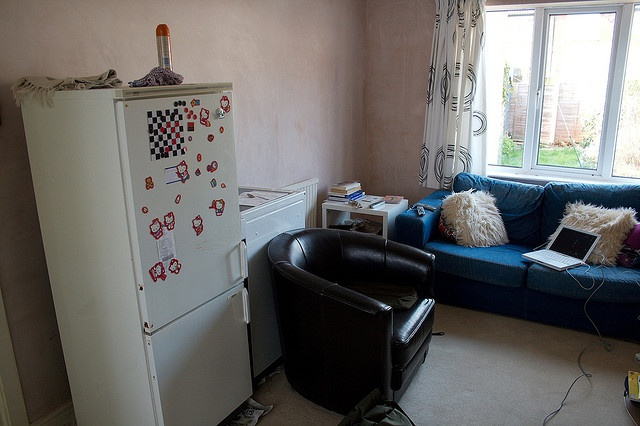Describe the objects in this image and their specific colors. I can see refrigerator in gray tones, chair in gray, black, and blue tones, couch in gray, black, navy, teal, and blue tones, laptop in gray, black, lightblue, and darkgray tones, and book in gray, darkgray, and maroon tones in this image. 